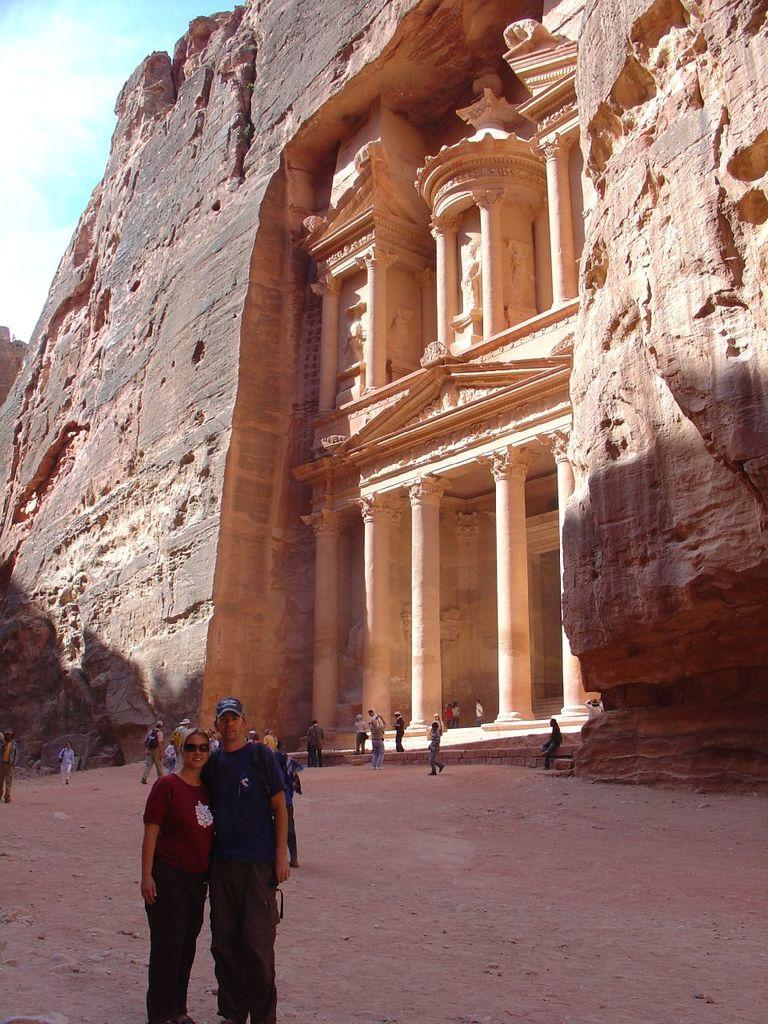What is the main structure in the image? There is a monument in the image. What can be seen in the background of the image? The sky is visible towards the top of the image. Who is present in the image? There are persons in the image. What are some of the persons wearing? Some persons are wearing bags. What architectural features can be seen in the image? There are pillars in the image. What type of artwork is present in the image? There are sculptors in the image. What type of snakes can be seen slithering around the monument in the image? There are no snakes present in the image; it features a monument with pillars and sculptors. What government organization is responsible for maintaining the monument in the image? The image does not provide information about the government organization responsible for maintaining the monument. 